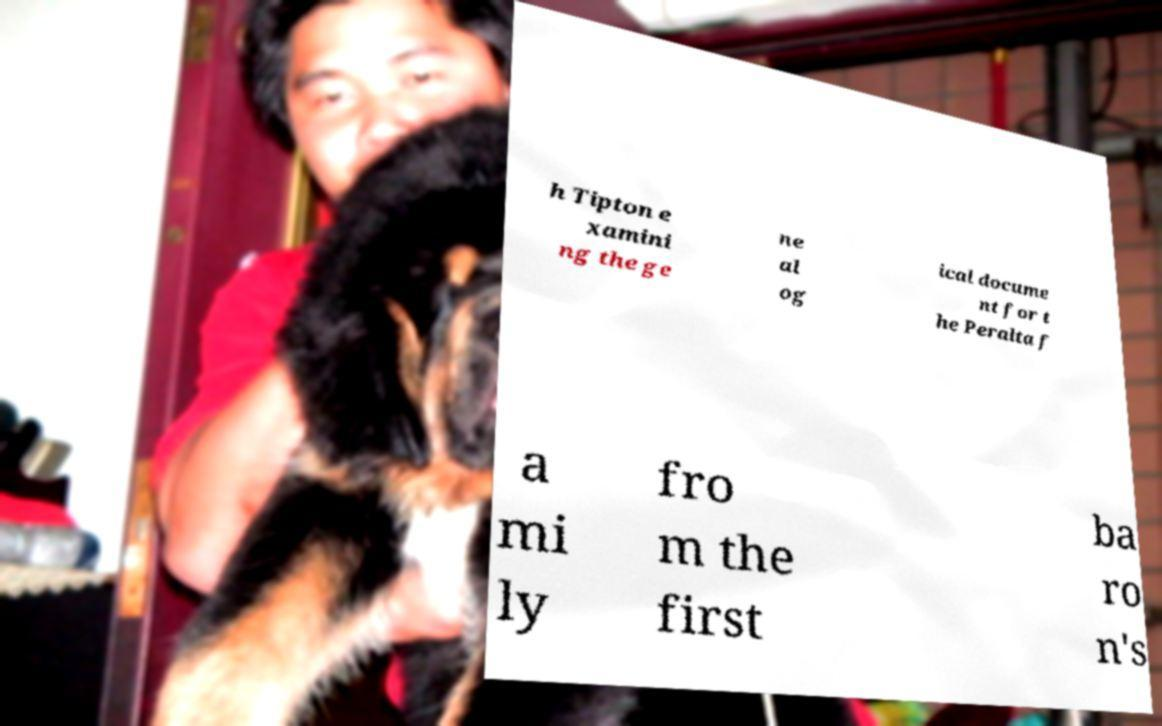I need the written content from this picture converted into text. Can you do that? h Tipton e xamini ng the ge ne al og ical docume nt for t he Peralta f a mi ly fro m the first ba ro n's 